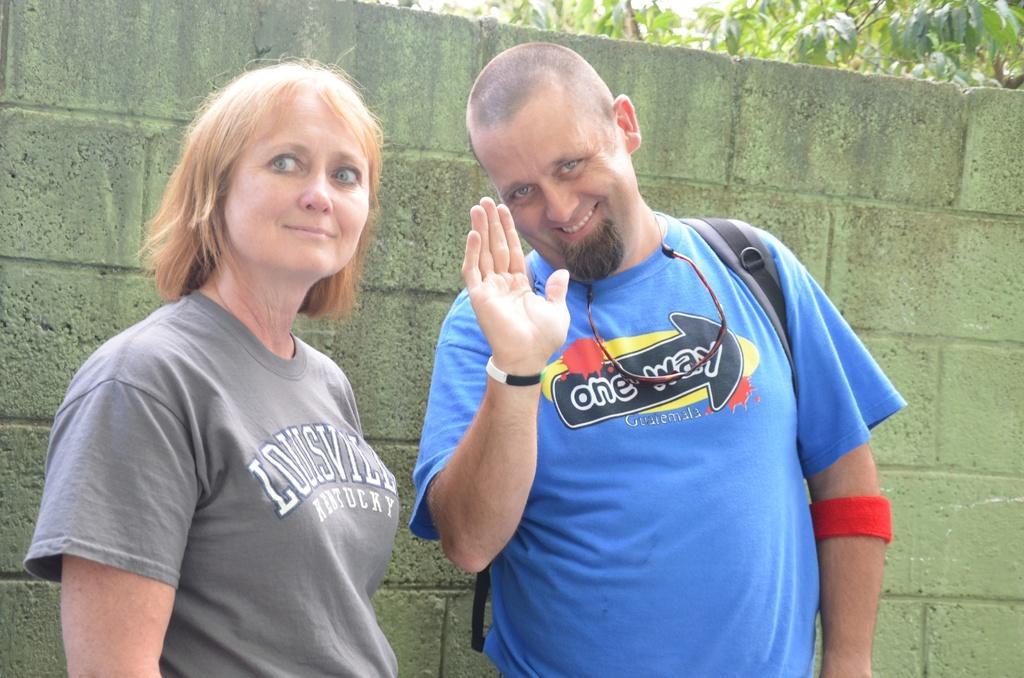Describe this image in one or two sentences. In this image there is a man on the right side and a woman on the left side. In the background there is a wall. Behind the wall there is a tree. The man is raising the hand. 